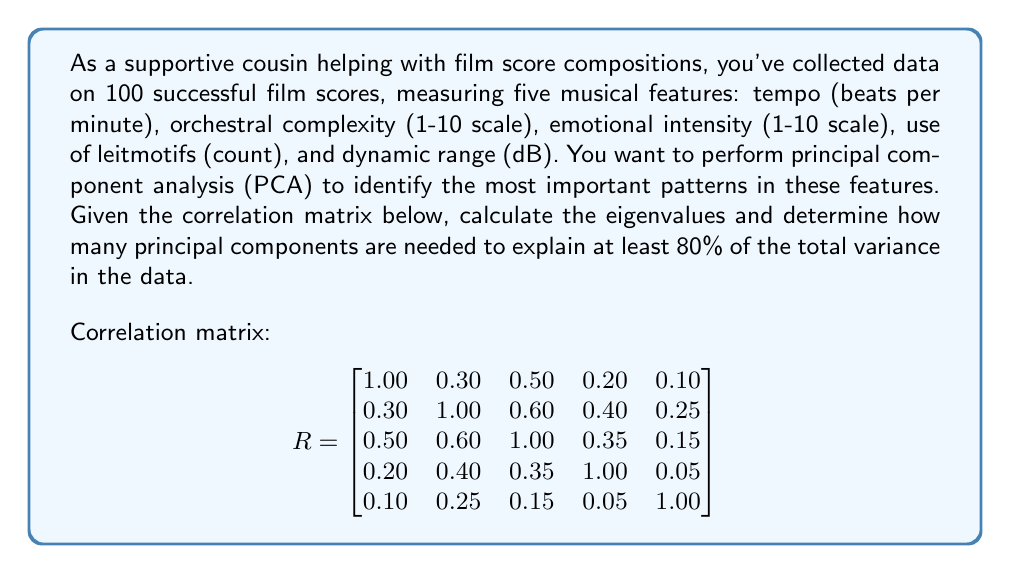Give your solution to this math problem. To solve this problem, we'll follow these steps:

1) Calculate the eigenvalues of the correlation matrix.
2) Compute the proportion of variance explained by each principal component.
3) Determine how many components are needed to explain at least 80% of the total variance.

Step 1: Calculate eigenvalues

We need to solve the characteristic equation $\det(R - \lambda I) = 0$. Using a computer algebra system or numerical methods, we find the eigenvalues:

$\lambda_1 \approx 2.4054$
$\lambda_2 \approx 1.0871$
$\lambda_3 \approx 0.6845$
$\lambda_4 \approx 0.4574$
$\lambda_5 \approx 0.3656$

Step 2: Compute proportion of variance explained

The total variance is the sum of all eigenvalues, which equals the number of variables (5 in this case). The proportion of variance explained by each component is its eigenvalue divided by the total variance:

$PC1: 2.4054 / 5 = 0.4811 \text{ or } 48.11\%$
$PC2: 1.0871 / 5 = 0.2174 \text{ or } 21.74\%$
$PC3: 0.6845 / 5 = 0.1369 \text{ or } 13.69\%$
$PC4: 0.4574 / 5 = 0.0915 \text{ or } 9.15\%$
$PC5: 0.3656 / 5 = 0.0731 \text{ or } 7.31\%$

Step 3: Determine number of components needed

We'll calculate the cumulative proportion of variance explained:

$PC1: 48.11\%$
$PC1 + PC2: 48.11\% + 21.74\% = 69.85\%$
$PC1 + PC2 + PC3: 69.85\% + 13.69\% = 83.54\%$

Therefore, the first three principal components explain more than 80% of the total variance in the data.
Answer: 3 principal components 